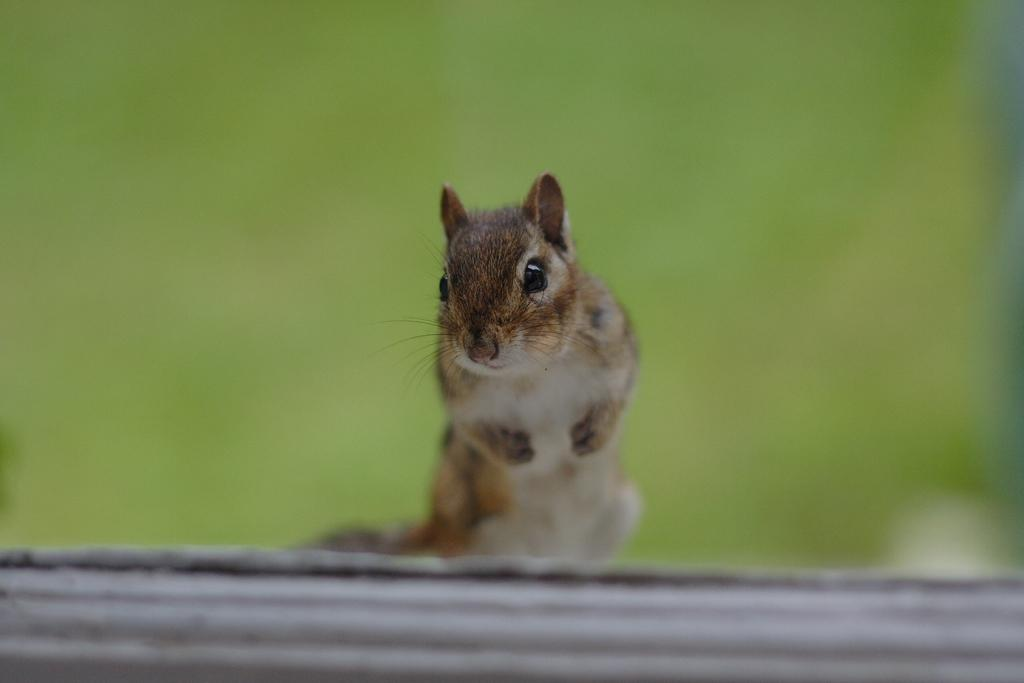What type of animal is in the image? There is a chipmunk in the image. Where is the chipmunk located? The chipmunk is on a surface. Can you describe the background of the image? The background of the image is blurry. What account does the chipmunk manage in the image? There is no mention of an account or management in the image; it simply features a chipmunk on a surface with a blurry background. 